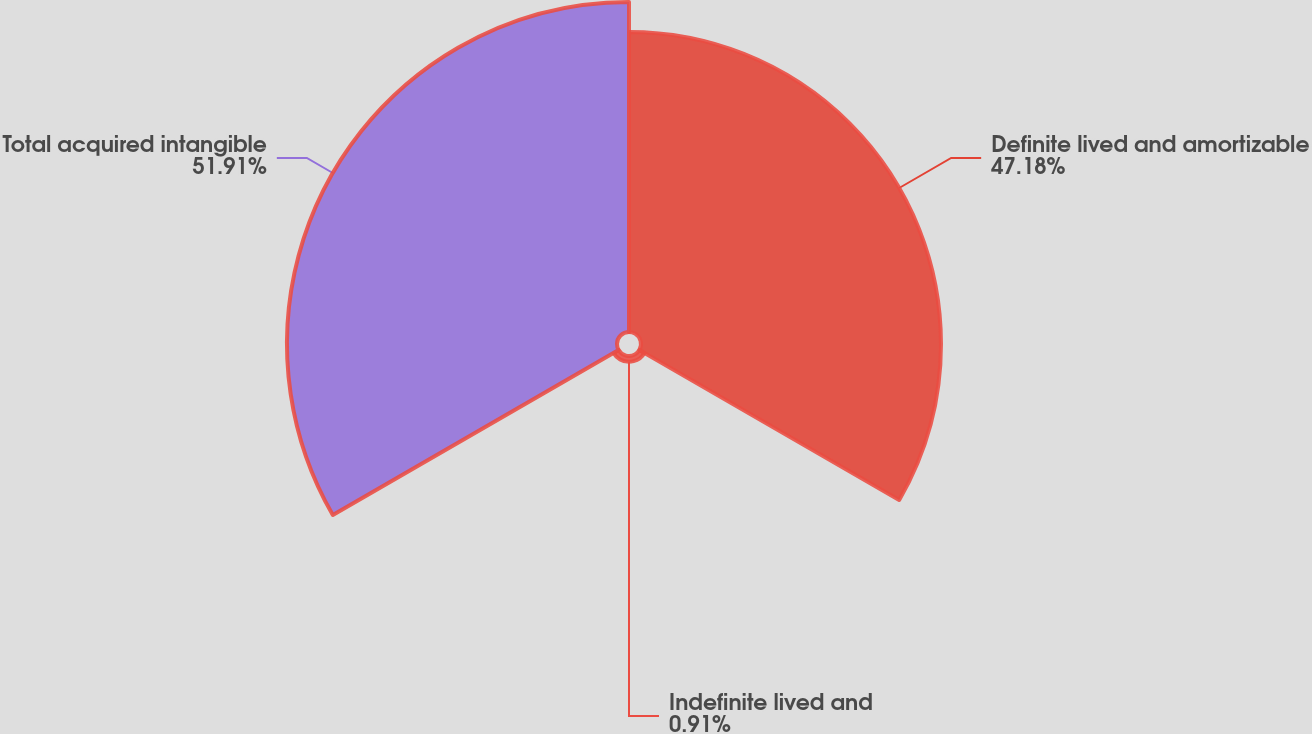Convert chart to OTSL. <chart><loc_0><loc_0><loc_500><loc_500><pie_chart><fcel>Definite lived and amortizable<fcel>Indefinite lived and<fcel>Total acquired intangible<nl><fcel>47.18%<fcel>0.91%<fcel>51.9%<nl></chart> 